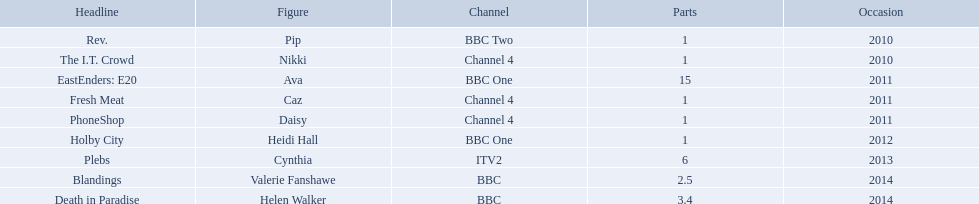What roles did she play? Pip, Nikki, Ava, Caz, Daisy, Heidi Hall, Cynthia, Valerie Fanshawe, Helen Walker. On which broadcasters? BBC Two, Channel 4, BBC One, Channel 4, Channel 4, BBC One, ITV2, BBC, BBC. Which roles did she play for itv2? Cynthia. 